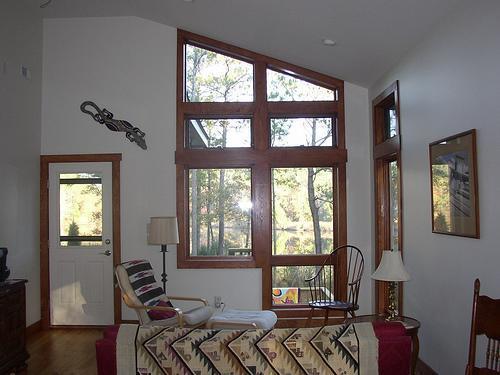How many chairs with cushions are there?
Give a very brief answer. 1. 